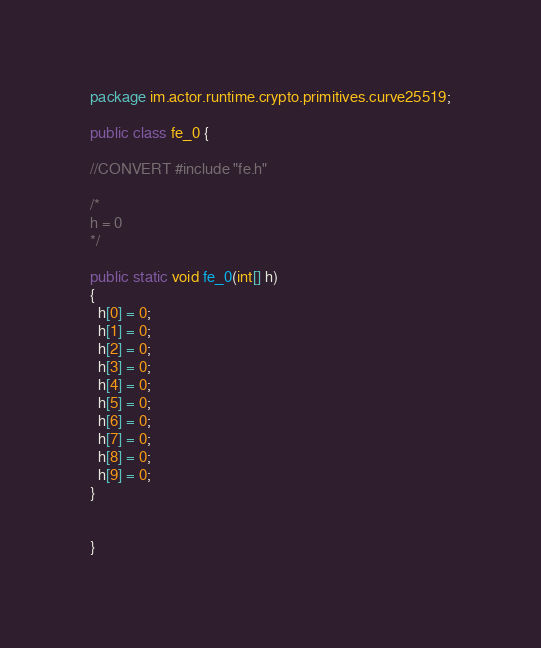Convert code to text. <code><loc_0><loc_0><loc_500><loc_500><_Java_>package im.actor.runtime.crypto.primitives.curve25519;

public class fe_0 {

//CONVERT #include "fe.h"

/*
h = 0
*/

public static void fe_0(int[] h)
{
  h[0] = 0;
  h[1] = 0;
  h[2] = 0;
  h[3] = 0;
  h[4] = 0;
  h[5] = 0;
  h[6] = 0;
  h[7] = 0;
  h[8] = 0;
  h[9] = 0;
}


}
</code> 